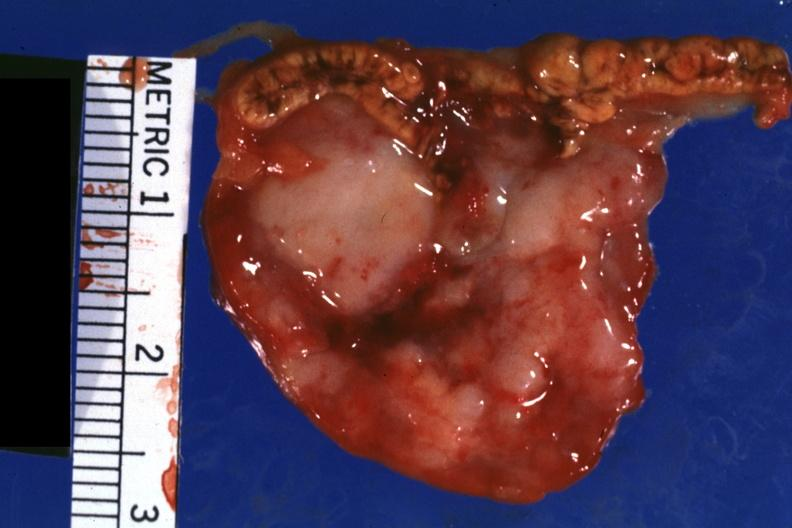how is photo?
Answer the question using a single word or phrase. Bloody 